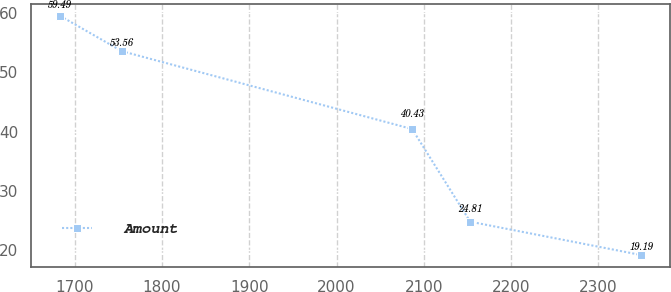Convert chart to OTSL. <chart><loc_0><loc_0><loc_500><loc_500><line_chart><ecel><fcel>Amount<nl><fcel>1683.53<fcel>59.49<nl><fcel>1753.95<fcel>53.56<nl><fcel>2086.64<fcel>40.43<nl><fcel>2153.2<fcel>24.81<nl><fcel>2349.1<fcel>19.19<nl></chart> 